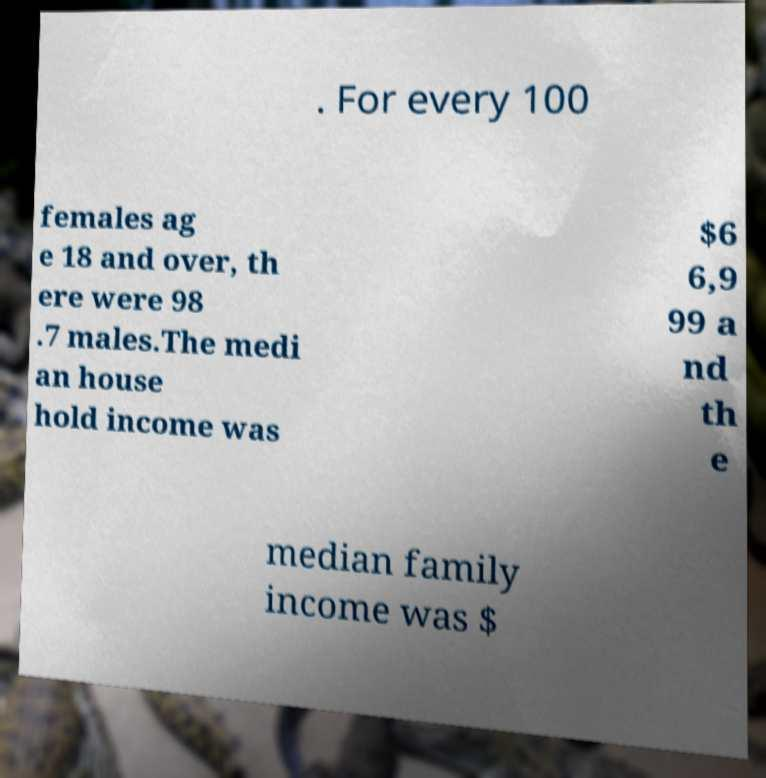There's text embedded in this image that I need extracted. Can you transcribe it verbatim? . For every 100 females ag e 18 and over, th ere were 98 .7 males.The medi an house hold income was $6 6,9 99 a nd th e median family income was $ 